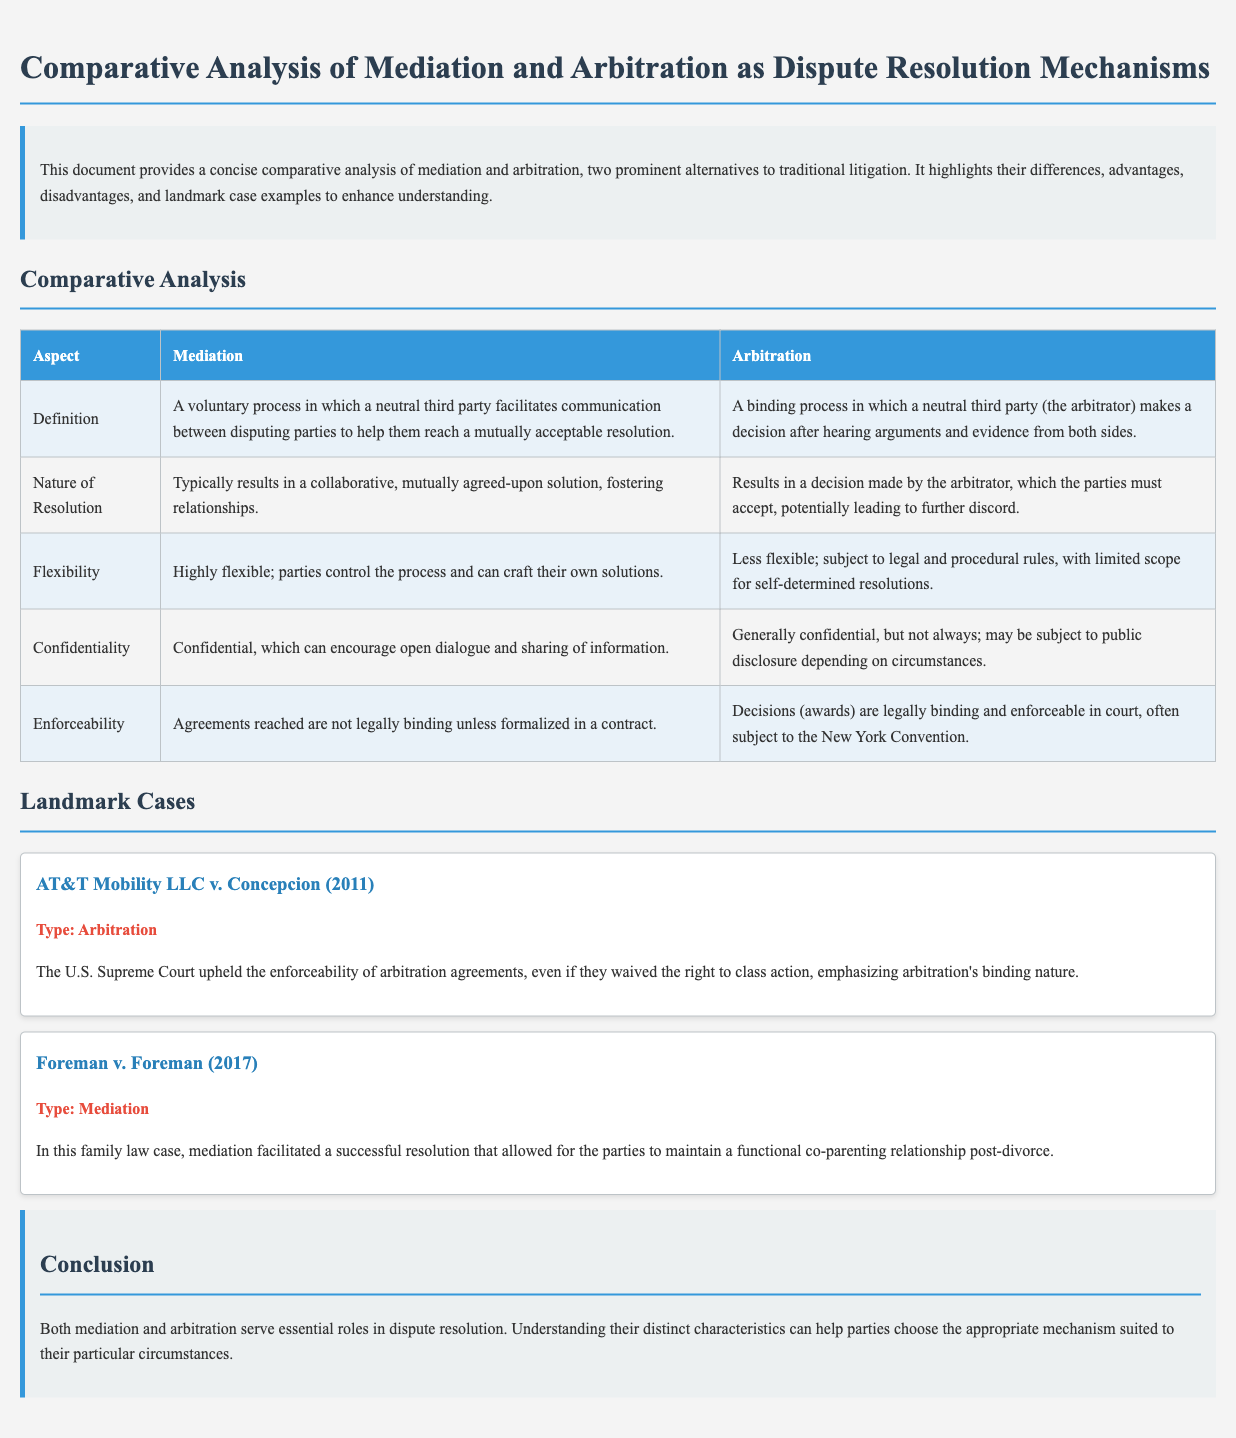What is the nature of resolution in mediation? Mediation typically results in a collaborative, mutually agreed-upon solution, as stated in the document.
Answer: Collaborative solution What is the enforceability of arbitration decisions? Arbitration decisions are legally binding and enforceable in court, which is specified in the table.
Answer: Legally binding Which landmark case highlighted the enforceability of arbitration agreements? The document mentions AT&T Mobility LLC v. Concepcion (2011) as a key case for arbitration enforceability.
Answer: AT&T Mobility LLC v. Concepcion What does mediation allow parties to maintain according to the Foreman case? The Foreman case illustrates that mediation can help maintain a functional co-parenting relationship post-divorce.
Answer: Functional co-parenting relationship How does the flexibility of mediation compare to arbitration? The document states that mediation is highly flexible, while arbitration is less flexible due to legal rules.
Answer: Highly flexible What is the definition of arbitration given in the document? The document defines arbitration as a binding process where a neutral third party makes a decision after hearing arguments and evidence.
Answer: Binding process What advantages does confidentiality provide in mediation? The document mentions that confidentiality encourages open dialogue and sharing of information in mediation.
Answer: Open dialogue What year was the AT&T Mobility LLC v. Concepcion case decided? The document indicates that the case was decided in 2011.
Answer: 2011 